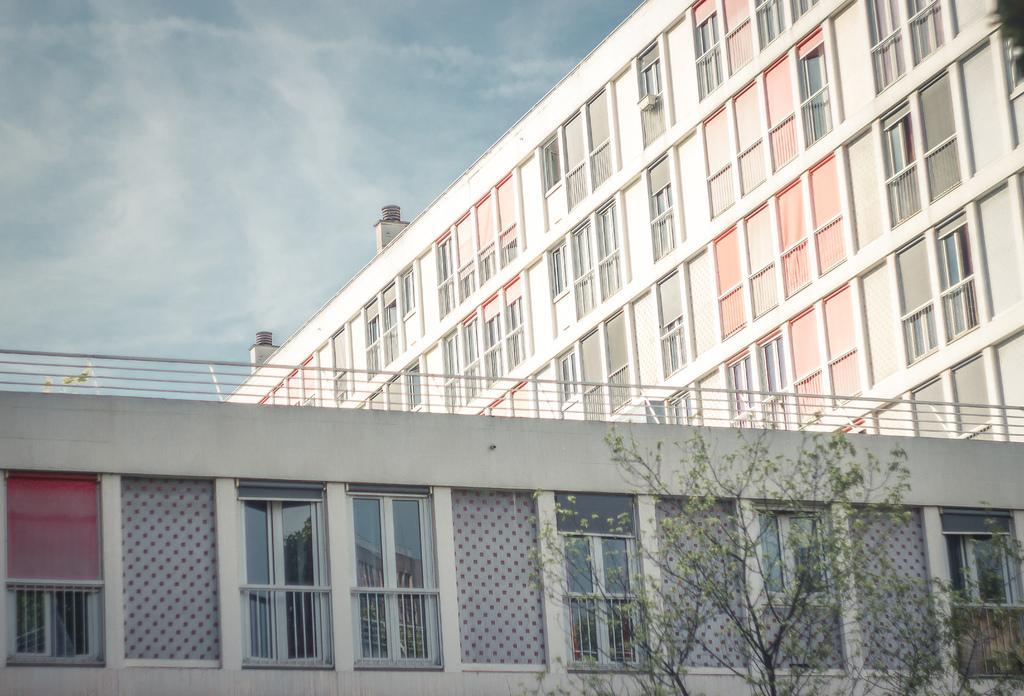How would you summarize this image in a sentence or two? In this image at the bottom and in the background there are buildings, in the foreground there are trees. At the top of the image there is sky. 